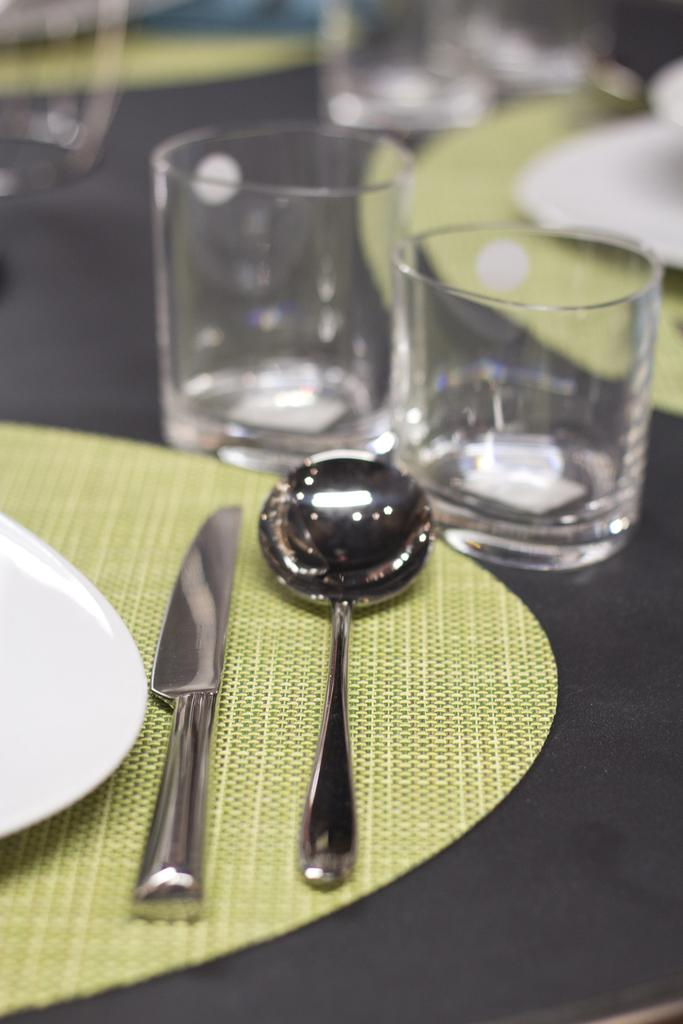What type of dishware is present in the image? There is a plate, a knife, and a spoon in the image. What type of beverage container is in the image? There is a glass in the image. What color is the table in the image? The table is black. How many arms are visible in the image? There are no arms visible in the image. What is the limit of the plate in the image? The plate in the image does not have a limit; it is a flat dishware item. 